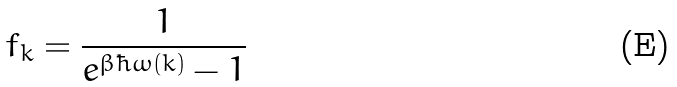Convert formula to latex. <formula><loc_0><loc_0><loc_500><loc_500>f _ { k } = \frac { 1 } { e ^ { \beta \hbar { \omega } ( k ) } - 1 }</formula> 